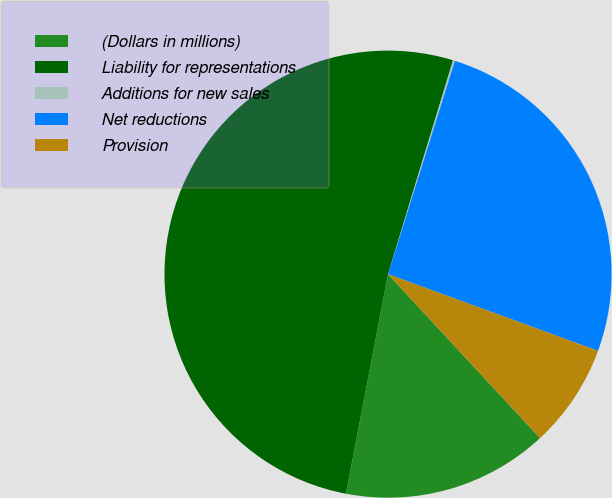<chart> <loc_0><loc_0><loc_500><loc_500><pie_chart><fcel>(Dollars in millions)<fcel>Liability for representations<fcel>Additions for new sales<fcel>Net reductions<fcel>Provision<nl><fcel>14.91%<fcel>51.68%<fcel>0.14%<fcel>25.74%<fcel>7.53%<nl></chart> 